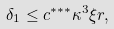Convert formula to latex. <formula><loc_0><loc_0><loc_500><loc_500>\delta _ { 1 } \leq c ^ { * * * } \kappa ^ { 3 } \xi r ,</formula> 